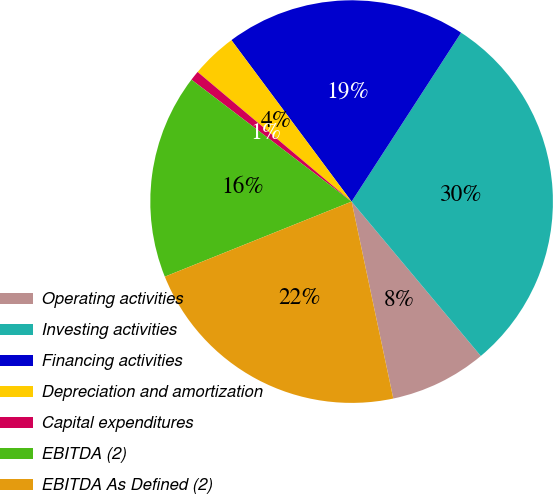<chart> <loc_0><loc_0><loc_500><loc_500><pie_chart><fcel>Operating activities<fcel>Investing activities<fcel>Financing activities<fcel>Depreciation and amortization<fcel>Capital expenditures<fcel>EBITDA (2)<fcel>EBITDA As Defined (2)<nl><fcel>7.77%<fcel>29.76%<fcel>19.34%<fcel>3.68%<fcel>0.78%<fcel>16.44%<fcel>22.24%<nl></chart> 